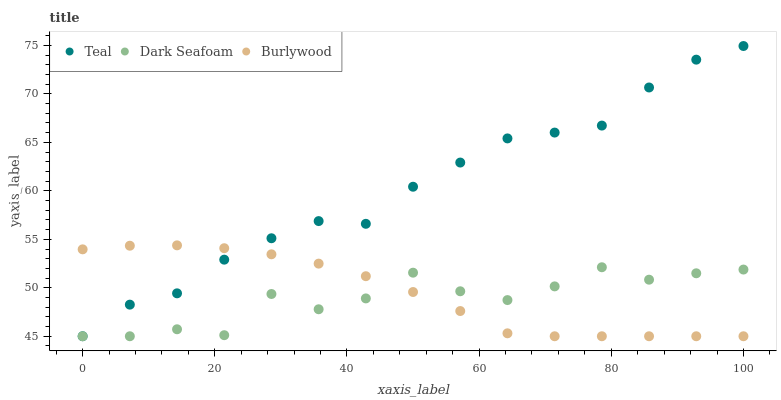Does Dark Seafoam have the minimum area under the curve?
Answer yes or no. Yes. Does Teal have the maximum area under the curve?
Answer yes or no. Yes. Does Teal have the minimum area under the curve?
Answer yes or no. No. Does Dark Seafoam have the maximum area under the curve?
Answer yes or no. No. Is Burlywood the smoothest?
Answer yes or no. Yes. Is Dark Seafoam the roughest?
Answer yes or no. Yes. Is Teal the smoothest?
Answer yes or no. No. Is Teal the roughest?
Answer yes or no. No. Does Burlywood have the lowest value?
Answer yes or no. Yes. Does Teal have the highest value?
Answer yes or no. Yes. Does Dark Seafoam have the highest value?
Answer yes or no. No. Does Burlywood intersect Dark Seafoam?
Answer yes or no. Yes. Is Burlywood less than Dark Seafoam?
Answer yes or no. No. Is Burlywood greater than Dark Seafoam?
Answer yes or no. No. 